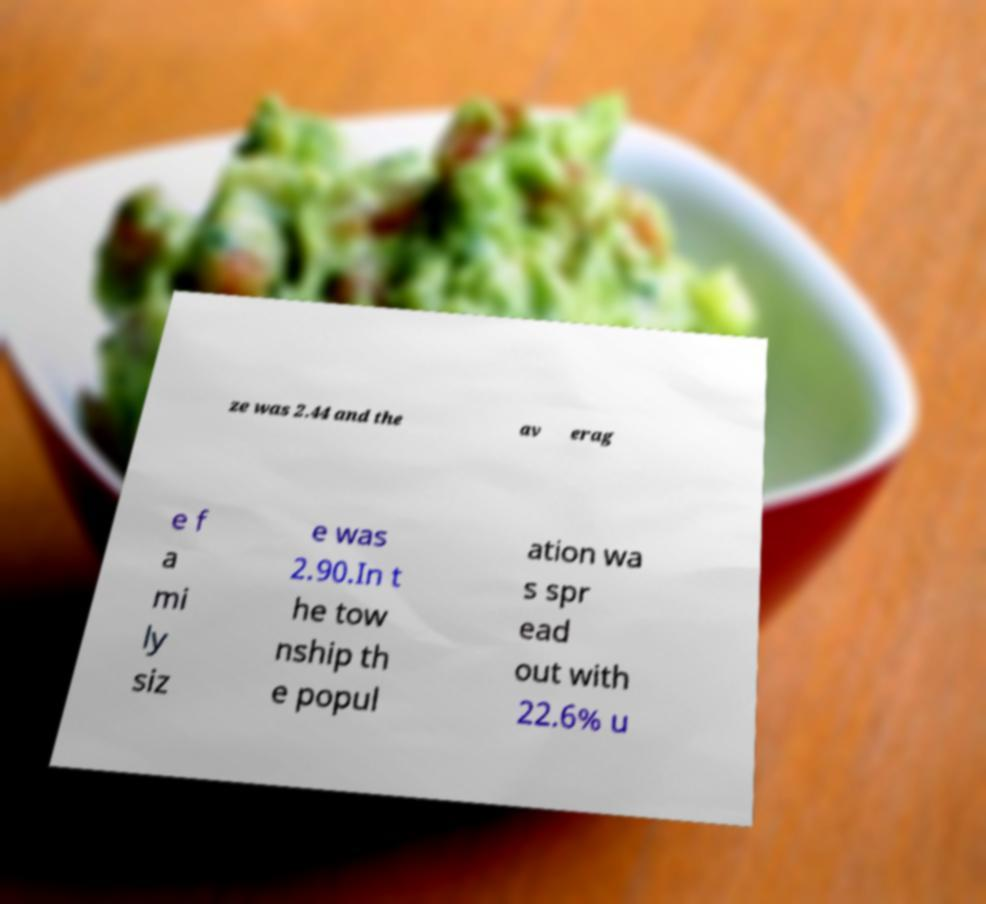Can you accurately transcribe the text from the provided image for me? ze was 2.44 and the av erag e f a mi ly siz e was 2.90.In t he tow nship th e popul ation wa s spr ead out with 22.6% u 